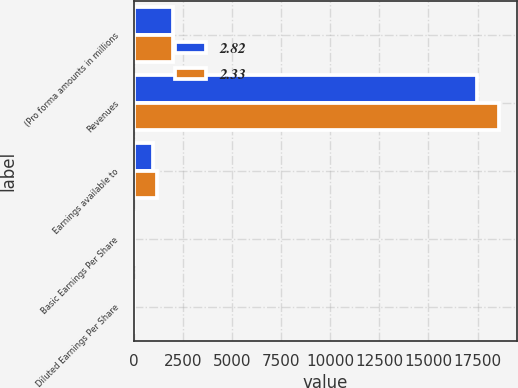Convert chart. <chart><loc_0><loc_0><loc_500><loc_500><stacked_bar_chart><ecel><fcel>(Pro forma amounts in millions<fcel>Revenues<fcel>Earnings available to<fcel>Basic Earnings Per Share<fcel>Diluted Earnings Per Share<nl><fcel>2.82<fcel>2011<fcel>17449<fcel>979<fcel>2.34<fcel>2.33<nl><fcel>2.33<fcel>2010<fcel>18569<fcel>1183<fcel>2.83<fcel>2.82<nl></chart> 